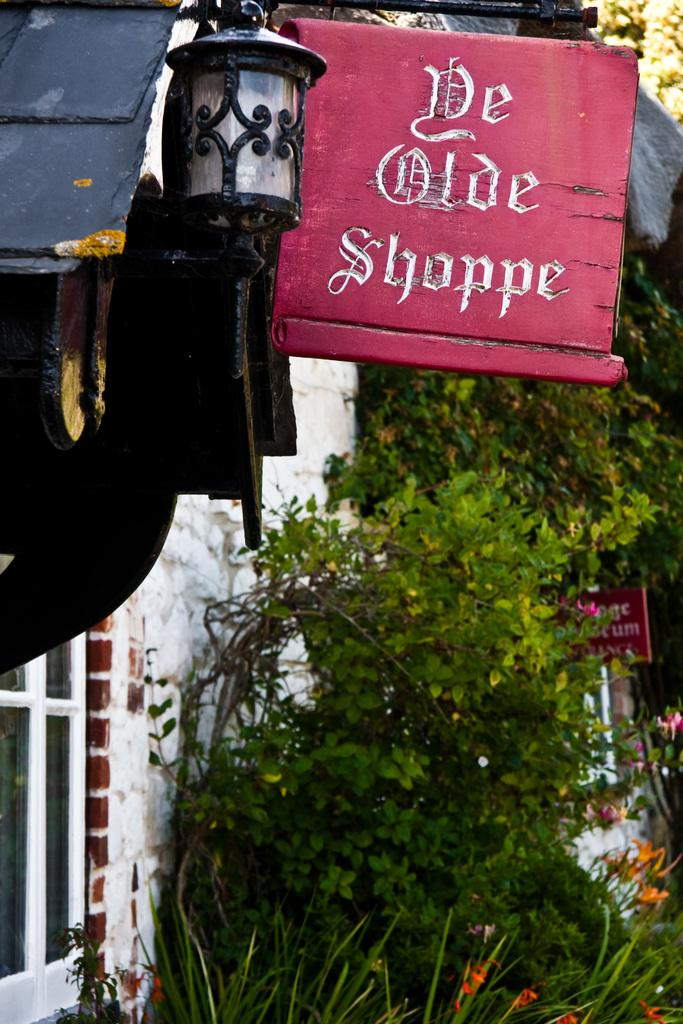What type of living organisms can be seen in the image? Plants can be seen in the image. What is the material of the sign board in the image? The sign board in the image is made of wood. What can be used to provide illumination in the image? There is a light visible in the image. What is the color of the fence on the left side of the image? The fence on the left side of the image is white. What letter does the maid in the image spell out with the plants? There is no maid present in the image, and therefore no such activity can be observed. 